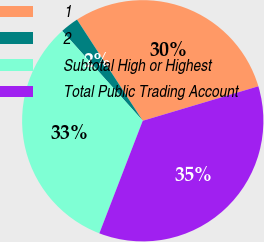<chart> <loc_0><loc_0><loc_500><loc_500><pie_chart><fcel>1<fcel>2<fcel>Subtotal High or Highest<fcel>Total Public Trading Account<nl><fcel>29.56%<fcel>2.46%<fcel>32.51%<fcel>35.47%<nl></chart> 